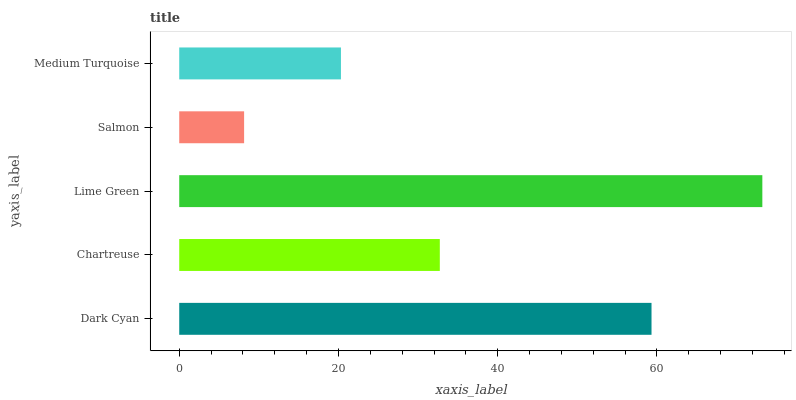Is Salmon the minimum?
Answer yes or no. Yes. Is Lime Green the maximum?
Answer yes or no. Yes. Is Chartreuse the minimum?
Answer yes or no. No. Is Chartreuse the maximum?
Answer yes or no. No. Is Dark Cyan greater than Chartreuse?
Answer yes or no. Yes. Is Chartreuse less than Dark Cyan?
Answer yes or no. Yes. Is Chartreuse greater than Dark Cyan?
Answer yes or no. No. Is Dark Cyan less than Chartreuse?
Answer yes or no. No. Is Chartreuse the high median?
Answer yes or no. Yes. Is Chartreuse the low median?
Answer yes or no. Yes. Is Salmon the high median?
Answer yes or no. No. Is Lime Green the low median?
Answer yes or no. No. 